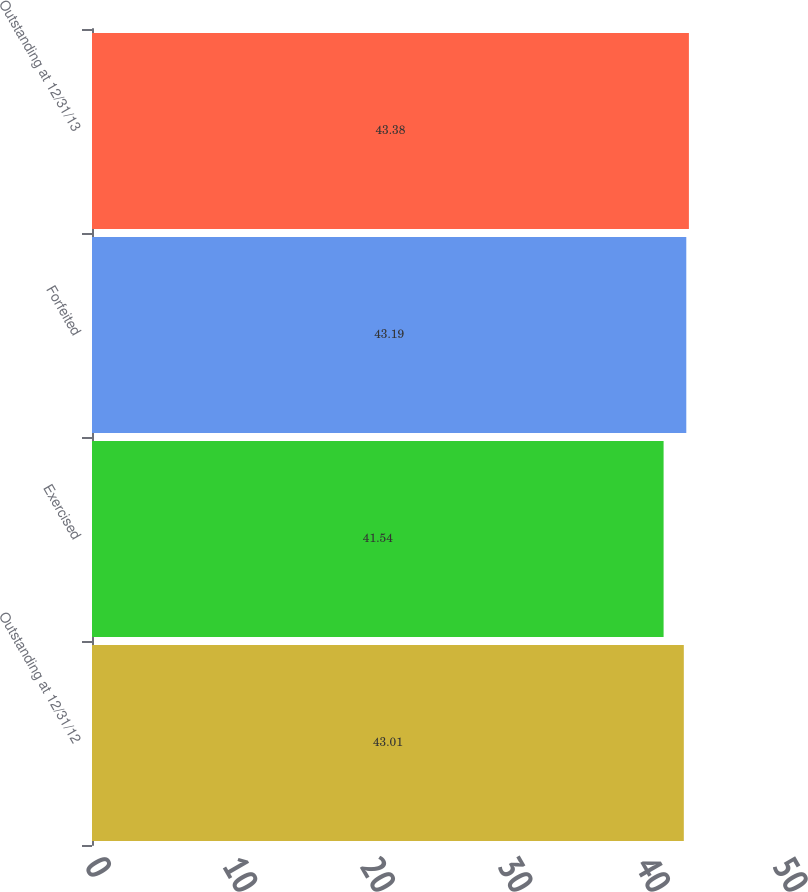<chart> <loc_0><loc_0><loc_500><loc_500><bar_chart><fcel>Outstanding at 12/31/12<fcel>Exercised<fcel>Forfeited<fcel>Outstanding at 12/31/13<nl><fcel>43.01<fcel>41.54<fcel>43.19<fcel>43.38<nl></chart> 